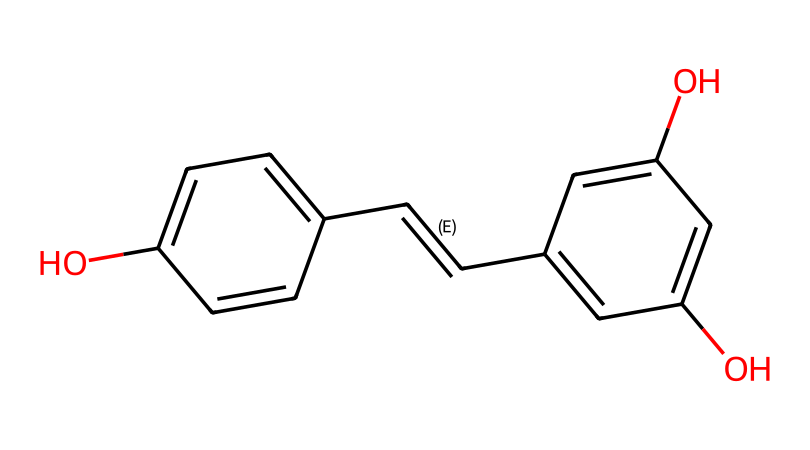How many hydroxyl (–OH) groups are present in resveratrol? The chemical structure shows two –OH groups attached to the aromatic rings, specifically at positions 3 and 5 on one ring and position 4 on the other.
Answer: 3 What is the molecular formula of resveratrol? Analyzing the structure reveals that it contains 14 carbon atoms, 12 hydrogen atoms, and 4 oxygen atoms, which is represented as C14H12O3.
Answer: C14H12O3 Is resveratrol planar? The entire structure consists of two aromatic rings connected by a double bond, which generally indicates a flat or planar conformation, allowing for effective stacking in biological systems.
Answer: Yes How many double bonds are in resveratrol? There are two double bonds present in the structure: one between the two carbon atoms connecting the aromatic rings, and the other in one of the rings itself.
Answer: 2 Which functional groups are present in resveratrol? The most notable functional groups in resveratrol include hydroxyl groups (–OH) and a styrene double bond (–C=C–), which are characteristic of its antioxidant activity.
Answer: hydroxyl and styrene What is a primary reason resveratrol is classified as an antioxidant? The presence of hydroxyl groups in the structure allows resveratrol to donate electrons and neutralize free radicals, which is the primary mechanism for its antioxidant activity.
Answer: electron donation How does the structure of resveratrol contribute to its solubility in alcohol? The hydroxyl groups can form hydrogen bonds with alcohol molecules, increasing its solubility despite the presence of hydrophobic aromatic rings in the structure.
Answer: hydrogen bonding 